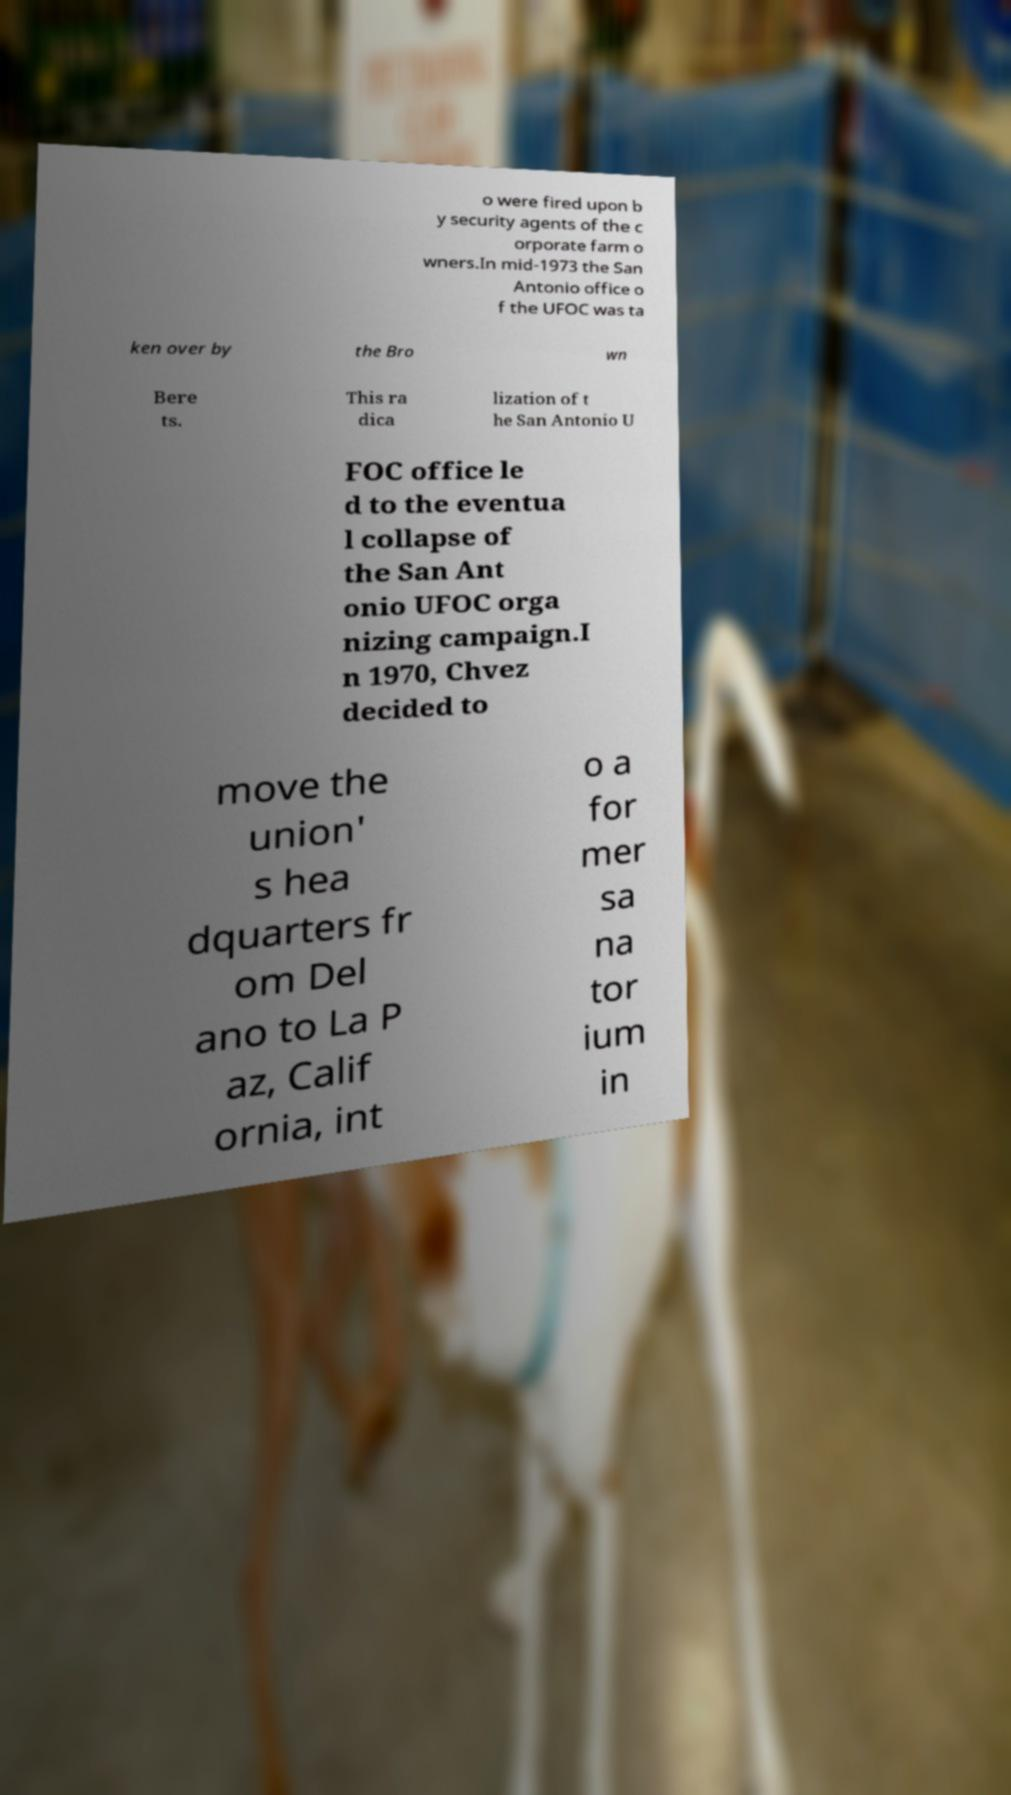There's text embedded in this image that I need extracted. Can you transcribe it verbatim? o were fired upon b y security agents of the c orporate farm o wners.In mid-1973 the San Antonio office o f the UFOC was ta ken over by the Bro wn Bere ts. This ra dica lization of t he San Antonio U FOC office le d to the eventua l collapse of the San Ant onio UFOC orga nizing campaign.I n 1970, Chvez decided to move the union' s hea dquarters fr om Del ano to La P az, Calif ornia, int o a for mer sa na tor ium in 